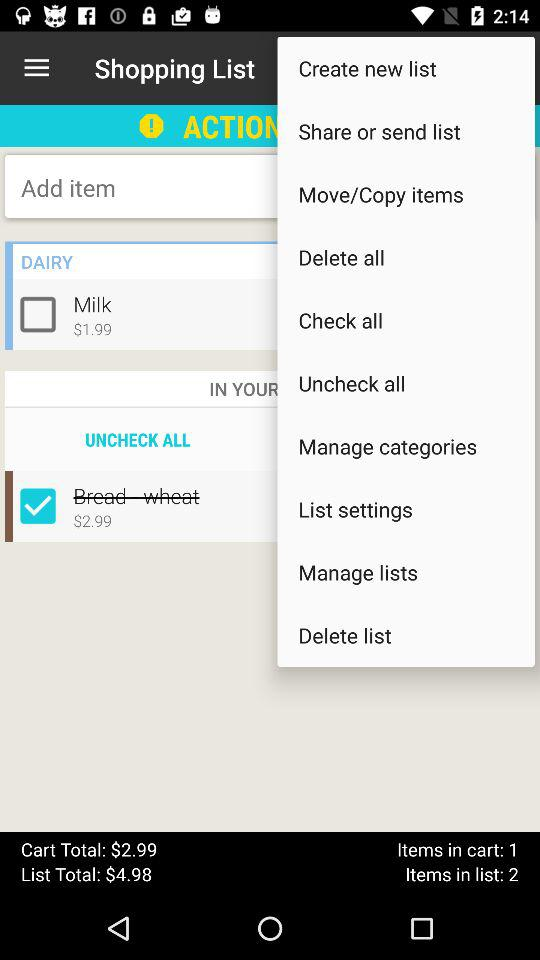How much more does the bread cost than the milk?
Answer the question using a single word or phrase. $1.00 